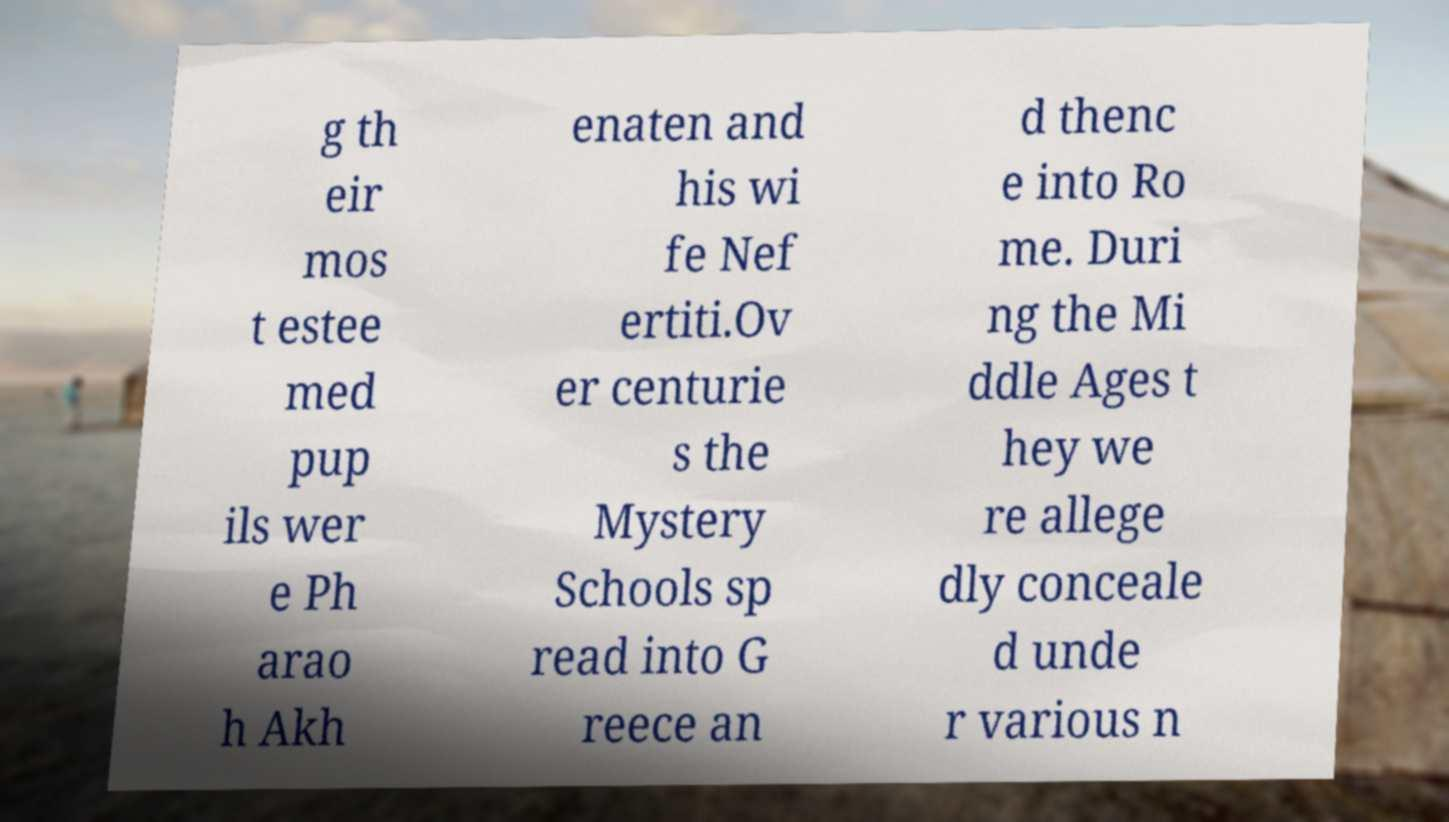Can you read and provide the text displayed in the image?This photo seems to have some interesting text. Can you extract and type it out for me? g th eir mos t estee med pup ils wer e Ph arao h Akh enaten and his wi fe Nef ertiti.Ov er centurie s the Mystery Schools sp read into G reece an d thenc e into Ro me. Duri ng the Mi ddle Ages t hey we re allege dly conceale d unde r various n 